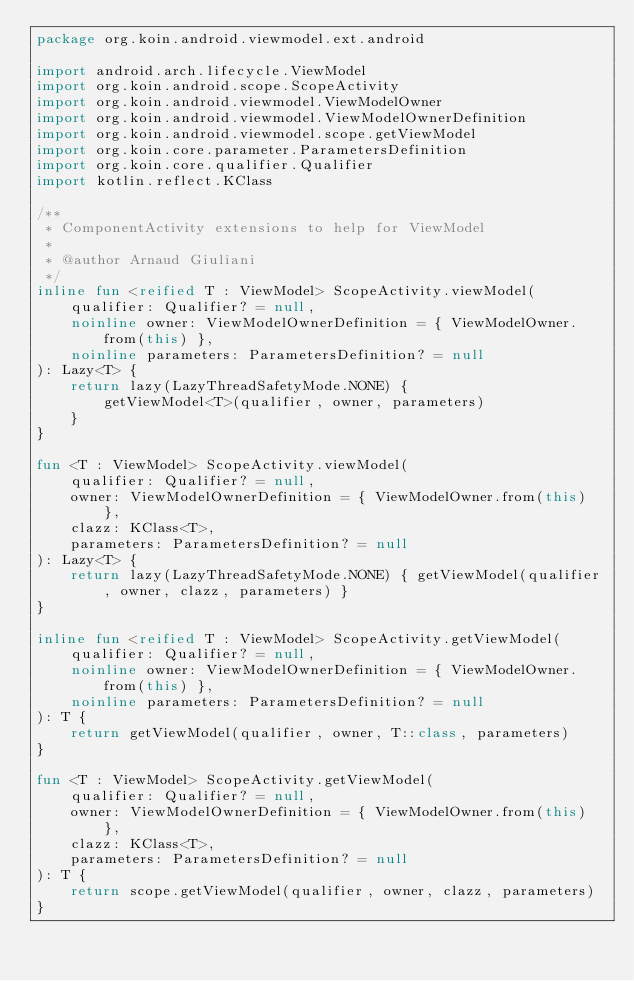<code> <loc_0><loc_0><loc_500><loc_500><_Kotlin_>package org.koin.android.viewmodel.ext.android

import android.arch.lifecycle.ViewModel
import org.koin.android.scope.ScopeActivity
import org.koin.android.viewmodel.ViewModelOwner
import org.koin.android.viewmodel.ViewModelOwnerDefinition
import org.koin.android.viewmodel.scope.getViewModel
import org.koin.core.parameter.ParametersDefinition
import org.koin.core.qualifier.Qualifier
import kotlin.reflect.KClass

/**
 * ComponentActivity extensions to help for ViewModel
 *
 * @author Arnaud Giuliani
 */
inline fun <reified T : ViewModel> ScopeActivity.viewModel(
    qualifier: Qualifier? = null,
    noinline owner: ViewModelOwnerDefinition = { ViewModelOwner.from(this) },
    noinline parameters: ParametersDefinition? = null
): Lazy<T> {
    return lazy(LazyThreadSafetyMode.NONE) {
        getViewModel<T>(qualifier, owner, parameters)
    }
}

fun <T : ViewModel> ScopeActivity.viewModel(
    qualifier: Qualifier? = null,
    owner: ViewModelOwnerDefinition = { ViewModelOwner.from(this) },
    clazz: KClass<T>,
    parameters: ParametersDefinition? = null
): Lazy<T> {
    return lazy(LazyThreadSafetyMode.NONE) { getViewModel(qualifier, owner, clazz, parameters) }
}

inline fun <reified T : ViewModel> ScopeActivity.getViewModel(
    qualifier: Qualifier? = null,
    noinline owner: ViewModelOwnerDefinition = { ViewModelOwner.from(this) },
    noinline parameters: ParametersDefinition? = null
): T {
    return getViewModel(qualifier, owner, T::class, parameters)
}

fun <T : ViewModel> ScopeActivity.getViewModel(
    qualifier: Qualifier? = null,
    owner: ViewModelOwnerDefinition = { ViewModelOwner.from(this) },
    clazz: KClass<T>,
    parameters: ParametersDefinition? = null
): T {
    return scope.getViewModel(qualifier, owner, clazz, parameters)
}</code> 